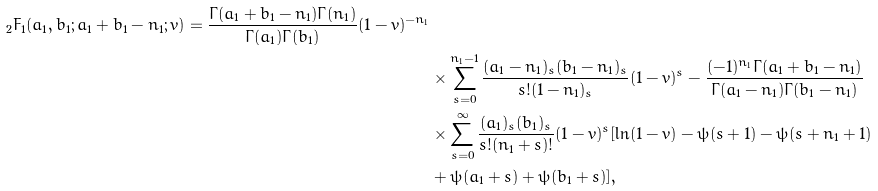<formula> <loc_0><loc_0><loc_500><loc_500>_ { 2 } F _ { 1 } ( a _ { 1 } , b _ { 1 } ; a _ { 1 } + b _ { 1 } - n _ { 1 } ; v ) = \frac { \Gamma ( a _ { 1 } + b _ { 1 } - n _ { 1 } ) \Gamma ( n _ { 1 } ) } { \Gamma ( a _ { 1 } ) \Gamma ( b _ { 1 } ) } ( 1 - v ) ^ { - n _ { 1 } } \\ & \times \sum _ { s = 0 } ^ { n _ { 1 } - 1 } \frac { ( a _ { 1 } - n _ { 1 } ) _ { s } ( b _ { 1 } - n _ { 1 } ) _ { s } } { s ! ( 1 - n _ { 1 } ) _ { s } } ( 1 - v ) ^ { s } - \frac { ( - 1 ) ^ { n _ { 1 } } \Gamma ( a _ { 1 } + b _ { 1 } - n _ { 1 } ) } { \Gamma ( a _ { 1 } - n _ { 1 } ) \Gamma ( b _ { 1 } - n _ { 1 } ) } \\ & \times \sum _ { s = 0 } ^ { \infty } \frac { ( a _ { 1 } ) _ { s } ( b _ { 1 } ) _ { s } } { s ! ( n _ { 1 } + s ) ! } ( 1 - v ) ^ { s } [ \ln ( 1 - v ) - \psi ( s + 1 ) - \psi ( s + n _ { 1 } + 1 ) \\ & + \psi ( a _ { 1 } + s ) + \psi ( b _ { 1 } + s ) ] ,</formula> 